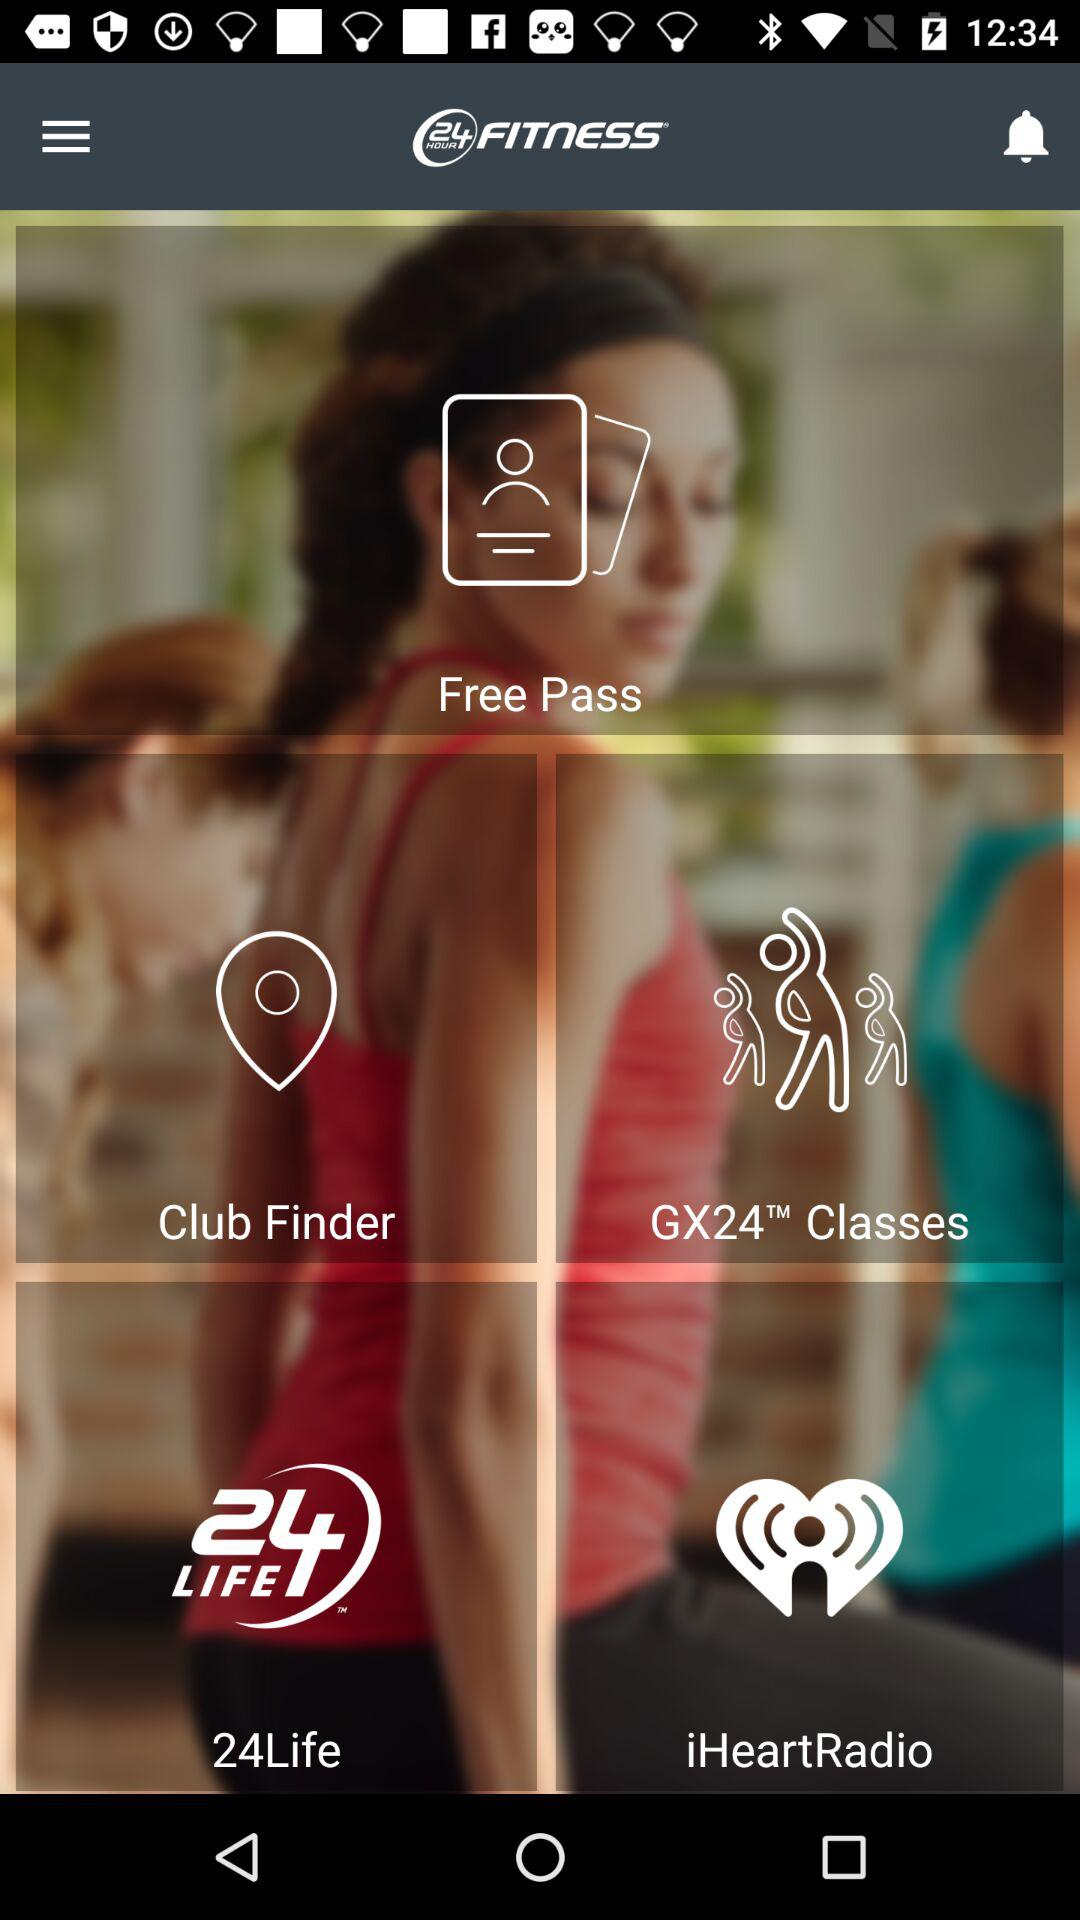What is the application name? The application name is "24 Hour fitness". 